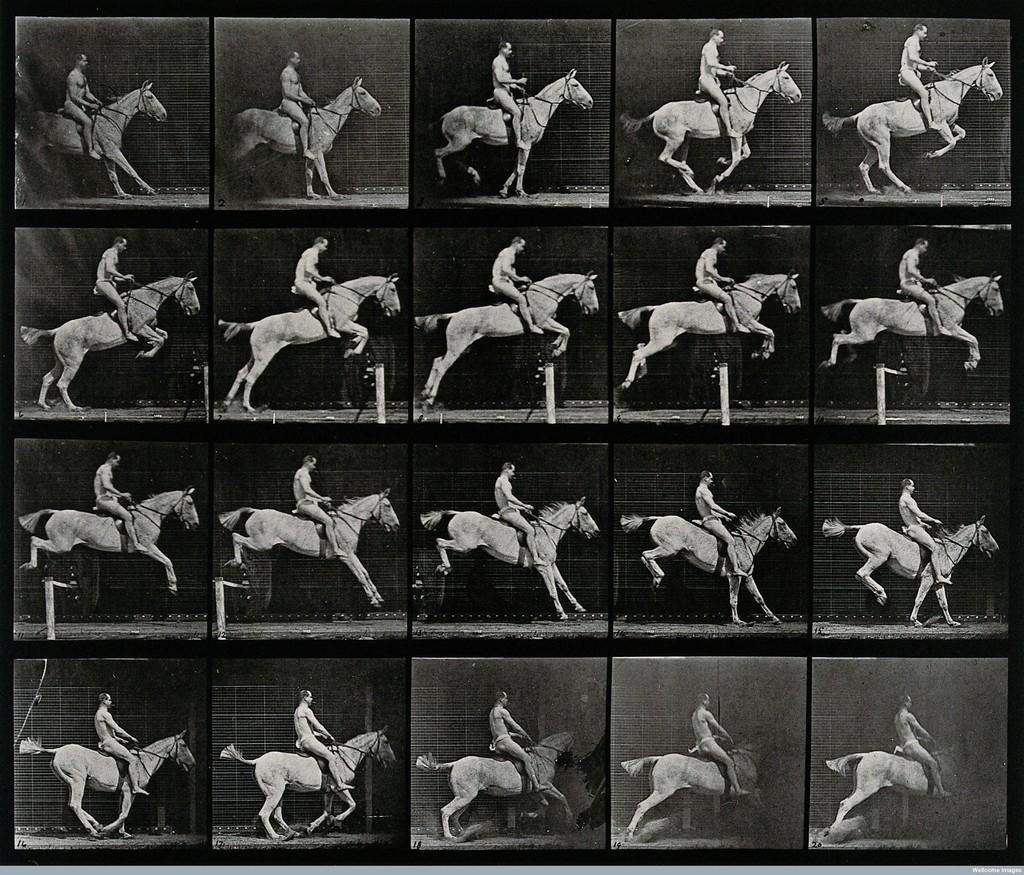In one or two sentences, can you explain what this image depicts? In this image I see a college and I see a man who is sitting on the horse and I see a hurdle over here. 